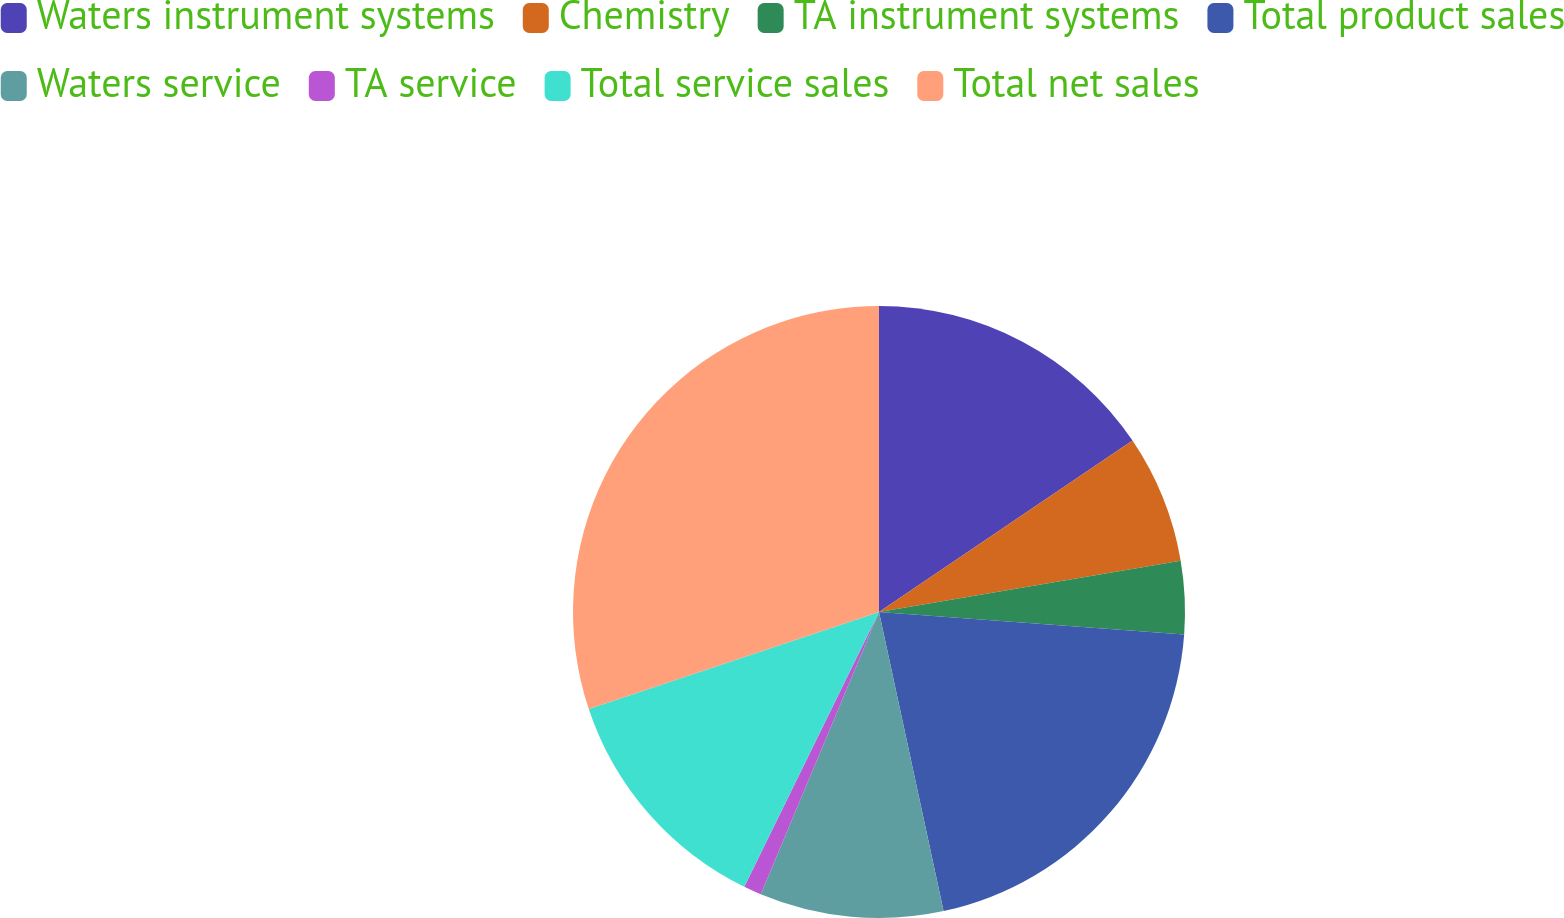Convert chart to OTSL. <chart><loc_0><loc_0><loc_500><loc_500><pie_chart><fcel>Waters instrument systems<fcel>Chemistry<fcel>TA instrument systems<fcel>Total product sales<fcel>Waters service<fcel>TA service<fcel>Total service sales<fcel>Total net sales<nl><fcel>15.54%<fcel>6.78%<fcel>3.86%<fcel>20.44%<fcel>9.7%<fcel>0.94%<fcel>12.62%<fcel>30.13%<nl></chart> 